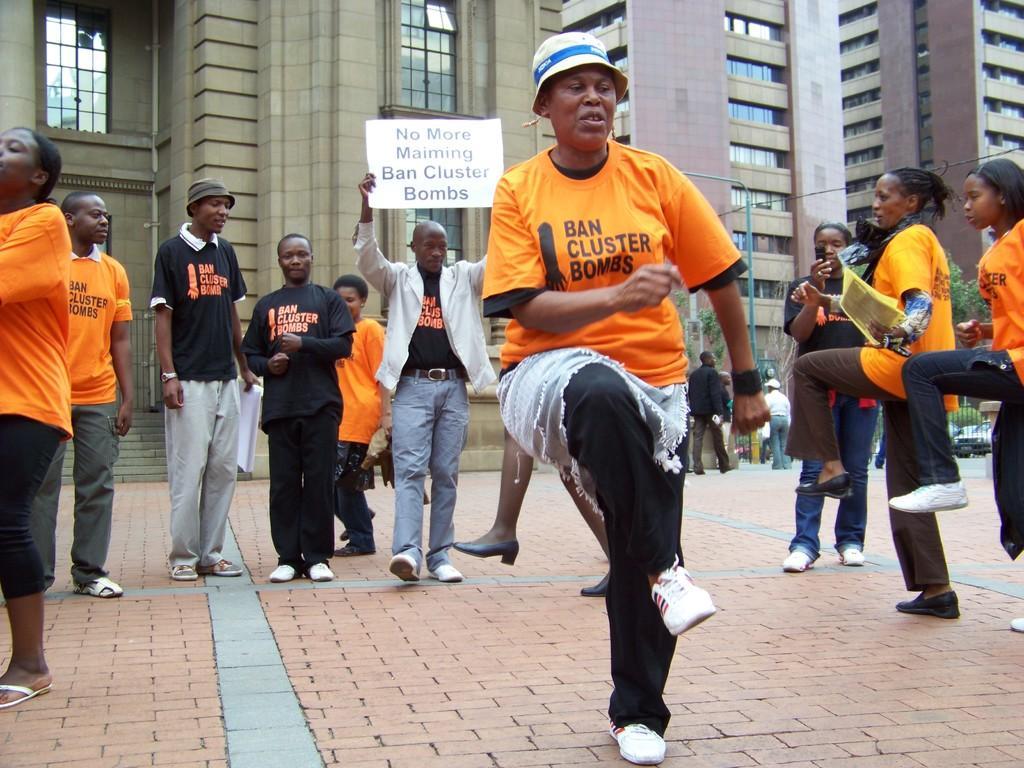Please provide a concise description of this image. In this image, we can see some people standing on the floor, in the middle we can see a man standing and he is holding a poster, in the background we can see some buildings, there are some windows on the buildings. 